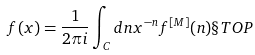<formula> <loc_0><loc_0><loc_500><loc_500>f ( x ) = \frac { 1 } { 2 \pi i } \int _ { C } d n x ^ { - n } f ^ { [ M ] } ( n ) \S T O P</formula> 